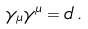<formula> <loc_0><loc_0><loc_500><loc_500>\gamma _ { \mu } \gamma ^ { \mu } = d \, .</formula> 